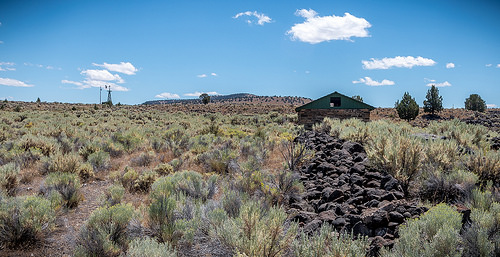<image>
Is there a structure on the cloud? No. The structure is not positioned on the cloud. They may be near each other, but the structure is not supported by or resting on top of the cloud. 